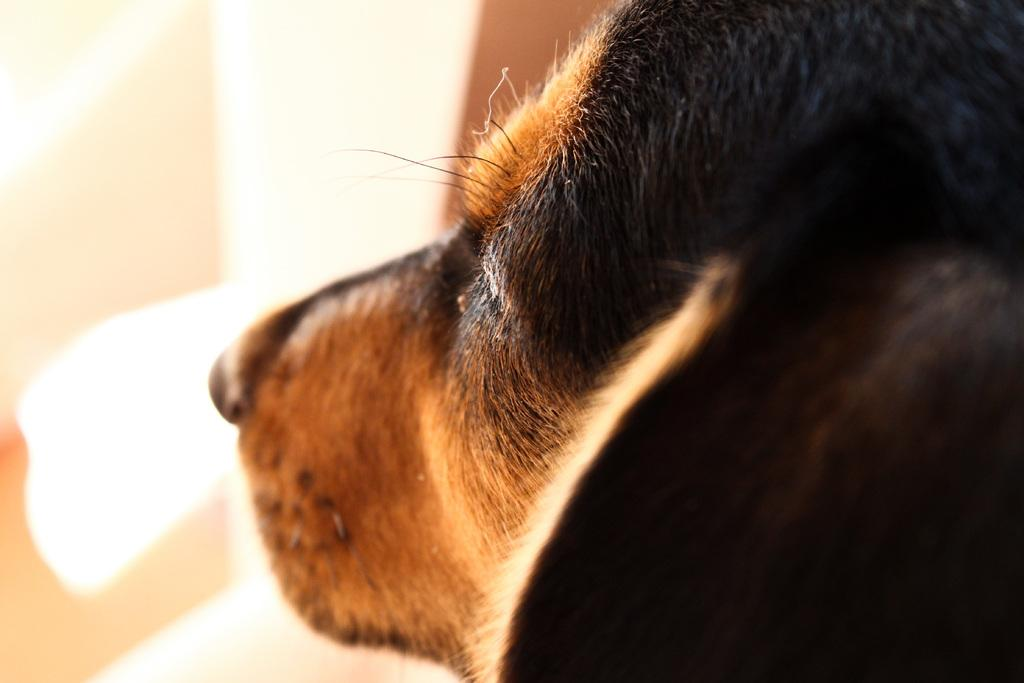What type of animal is in the image? There is a dog in the image. What colors can be seen on the dog? The dog has black and brown colors. What color is the background of the image? The background of the image is white. Is the dog drinking eggnog in the image? There is no eggnog present in the image, and the dog is not shown drinking anything. 